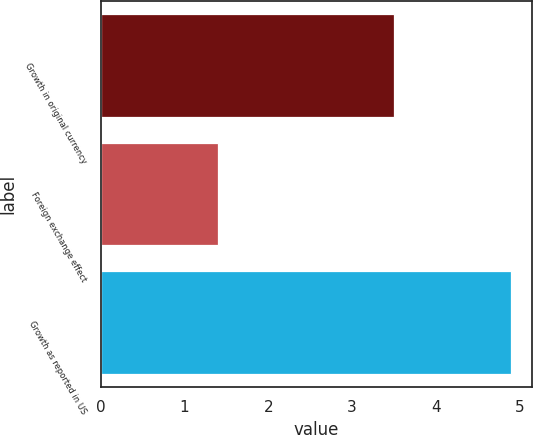<chart> <loc_0><loc_0><loc_500><loc_500><bar_chart><fcel>Growth in original currency<fcel>Foreign exchange effect<fcel>Growth as reported in US<nl><fcel>3.5<fcel>1.4<fcel>4.9<nl></chart> 